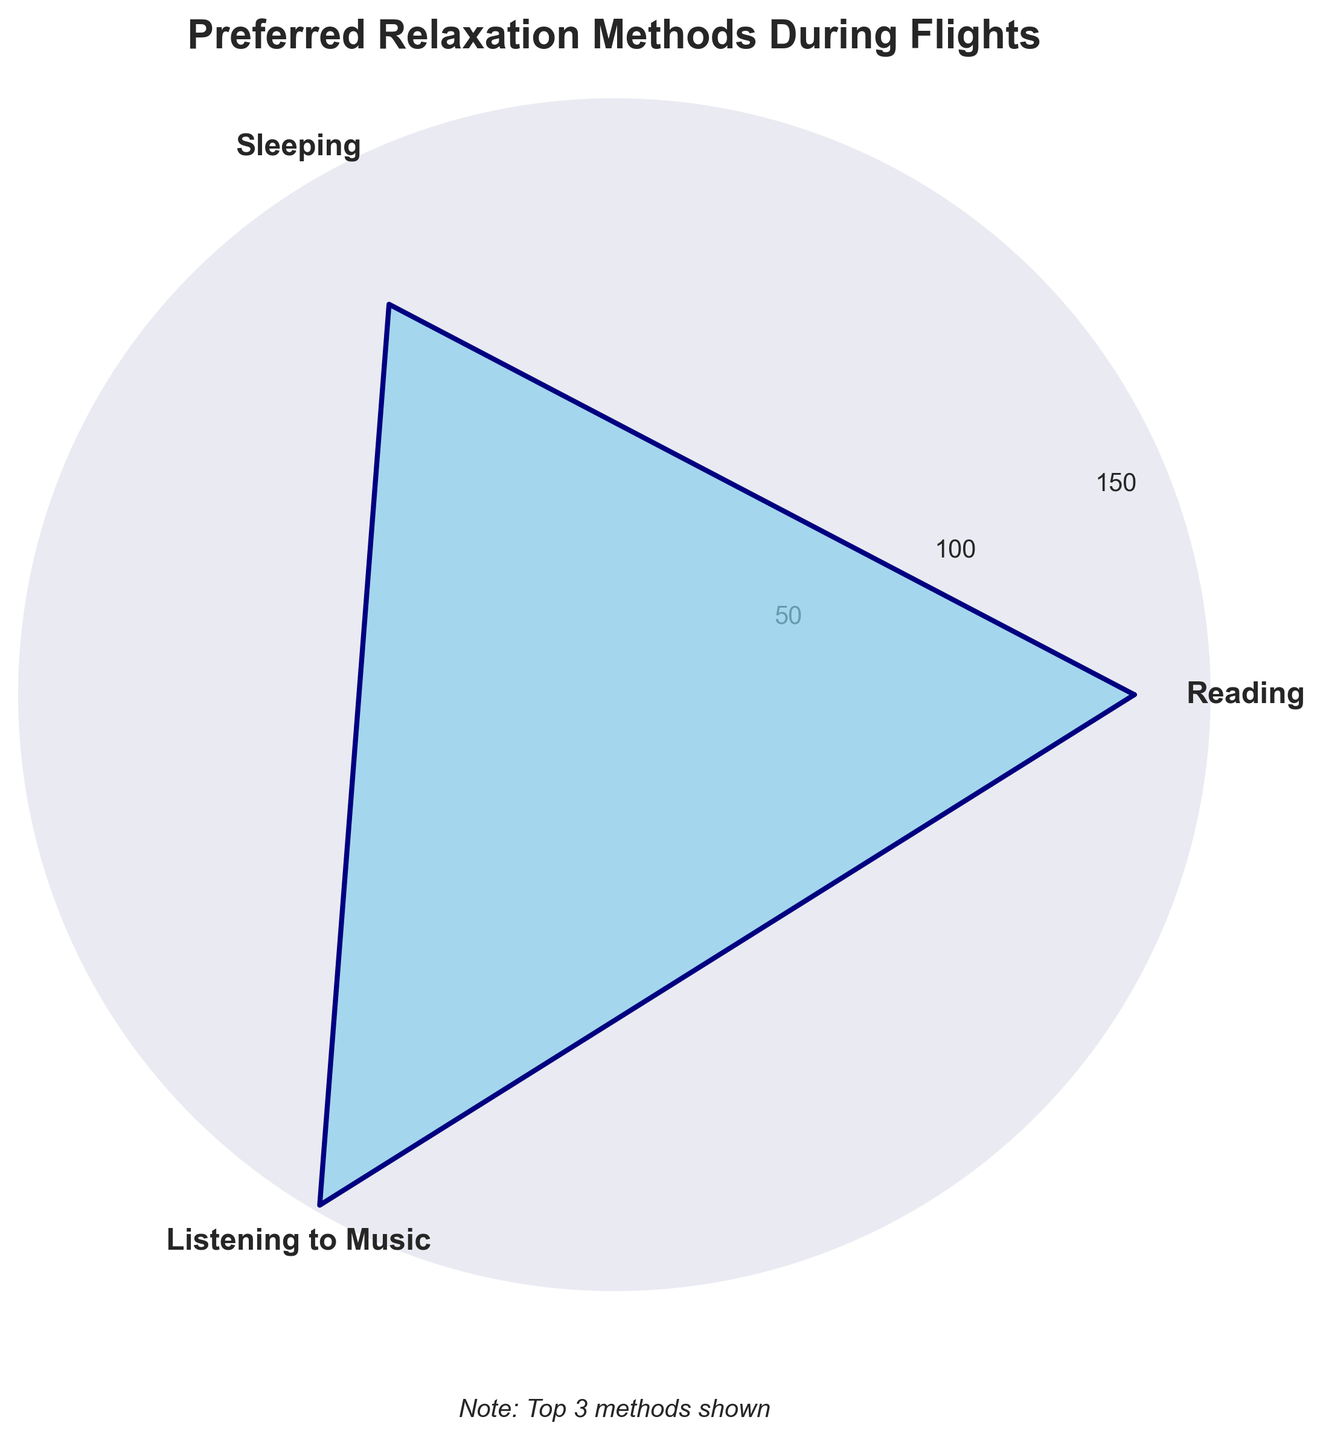Which relaxation method is most preferred during flights? The method with the largest area and longest radial line is the most preferred. The longest line corresponds to "Listening to Music"
Answer: Listening to Music What is the title of the figure? Look at the text above the plot, which describes what the plot is showing
Answer: Preferred Relaxation Methods During Flights How many periods (spikes) are shown on the rose chart? Count the number of distinct spikes or data points in the polar plot
Answer: 3 What is the smallest radial value shown in the figure? Check the radial (circular) axis of the rose chart to find the minimum labeled value
Answer: 50 How many people prefer sleeping compared to reading? Observe the length of radial lines for "Sleeping" and "Reading" and get the values. Subtract the smaller value from the larger one (150 - 130)
Answer: 20 Is listening to music more popular than sleeping during flights? Compare the lengths of the radial lines representing "Listening to Music" and "Sleeping"
Answer: Yes By how much does the frequency of people who prefer listening to music exceed those who prefer reading? Subtract the frequency of "Reading" (150) from "Listening to Music" (170)
Answer: 20 Compared to reading and sleeping, which relaxation method is the least popular? Compare the lengths of the radial lines for each relaxation method; the shortest one represents the least popular method
Answer: Sleeping What are the radial tick increments shown in the figure? Look at the distance between radial ticks (50, 100, 150, etc.)
Answer: 50 What is the total number of people included for the top three methods? Add the frequencies of Reading (150), Sleeping (130), and Listening to Music (170)
Answer: 450 